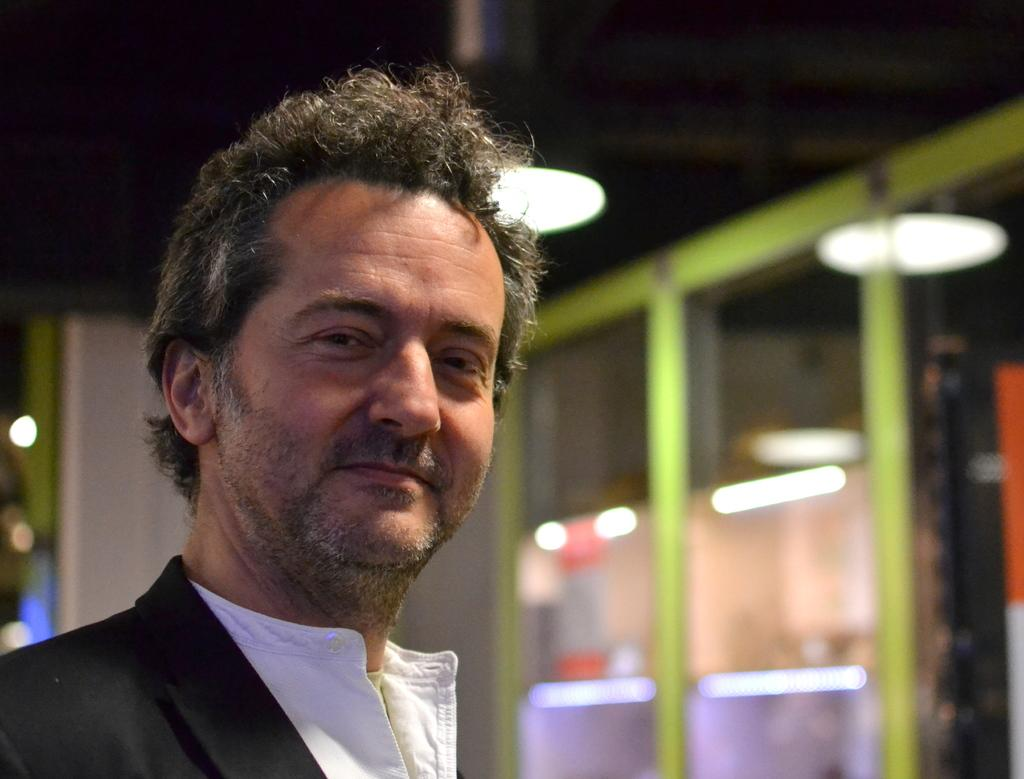Who or what is present in the image? There is a person in the image. What can be seen in the background or surrounding the person? There are lights and glass partitions in the image. How do the waves interact with the person in the image? There are no waves present in the image; it only features a person, lights, and glass partitions. 